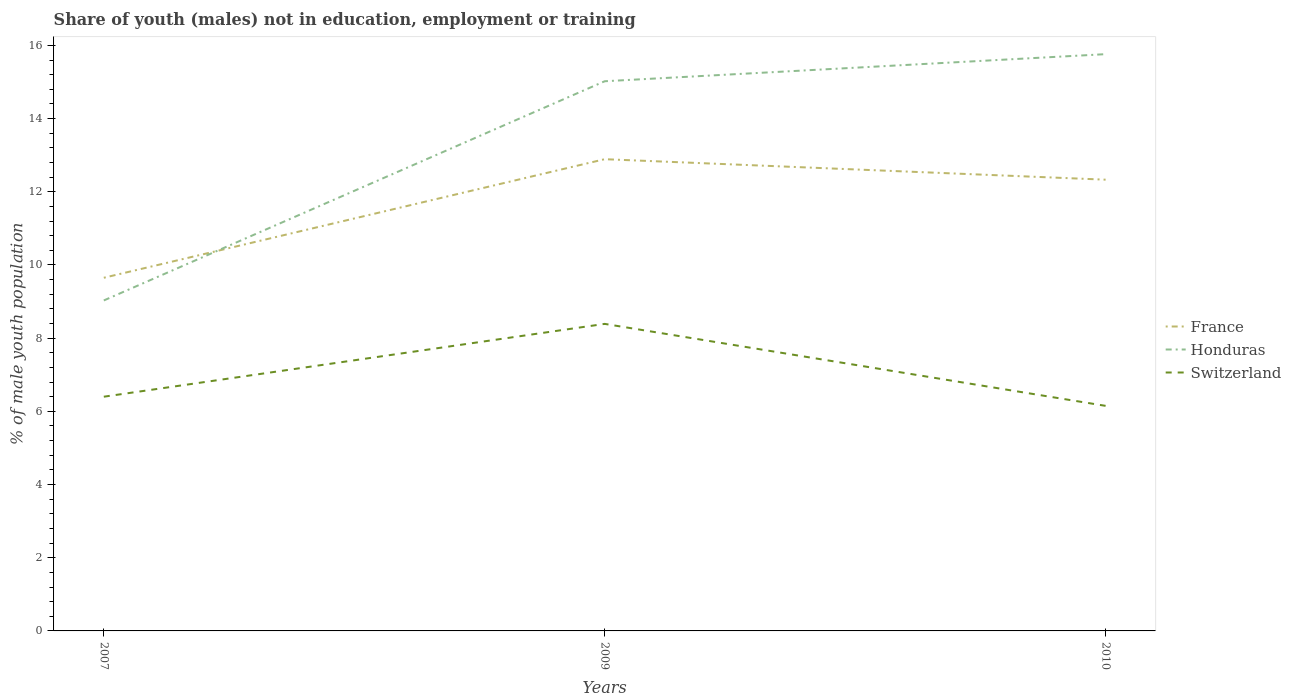How many different coloured lines are there?
Give a very brief answer. 3. Does the line corresponding to France intersect with the line corresponding to Honduras?
Keep it short and to the point. Yes. Is the number of lines equal to the number of legend labels?
Offer a very short reply. Yes. Across all years, what is the maximum percentage of unemployed males population in in France?
Offer a very short reply. 9.65. In which year was the percentage of unemployed males population in in Switzerland maximum?
Offer a terse response. 2010. What is the total percentage of unemployed males population in in France in the graph?
Offer a terse response. -2.68. What is the difference between the highest and the second highest percentage of unemployed males population in in Honduras?
Ensure brevity in your answer.  6.73. Is the percentage of unemployed males population in in France strictly greater than the percentage of unemployed males population in in Switzerland over the years?
Your answer should be very brief. No. How many lines are there?
Provide a short and direct response. 3. What is the difference between two consecutive major ticks on the Y-axis?
Provide a succinct answer. 2. Does the graph contain grids?
Your answer should be compact. No. Where does the legend appear in the graph?
Provide a succinct answer. Center right. How many legend labels are there?
Give a very brief answer. 3. What is the title of the graph?
Offer a terse response. Share of youth (males) not in education, employment or training. What is the label or title of the Y-axis?
Offer a very short reply. % of male youth population. What is the % of male youth population in France in 2007?
Your response must be concise. 9.65. What is the % of male youth population of Honduras in 2007?
Give a very brief answer. 9.03. What is the % of male youth population of Switzerland in 2007?
Make the answer very short. 6.4. What is the % of male youth population in France in 2009?
Make the answer very short. 12.89. What is the % of male youth population in Honduras in 2009?
Keep it short and to the point. 15.02. What is the % of male youth population of Switzerland in 2009?
Provide a short and direct response. 8.39. What is the % of male youth population of France in 2010?
Your answer should be very brief. 12.33. What is the % of male youth population in Honduras in 2010?
Provide a succinct answer. 15.76. What is the % of male youth population in Switzerland in 2010?
Your response must be concise. 6.15. Across all years, what is the maximum % of male youth population of France?
Keep it short and to the point. 12.89. Across all years, what is the maximum % of male youth population in Honduras?
Ensure brevity in your answer.  15.76. Across all years, what is the maximum % of male youth population in Switzerland?
Provide a succinct answer. 8.39. Across all years, what is the minimum % of male youth population of France?
Your answer should be compact. 9.65. Across all years, what is the minimum % of male youth population of Honduras?
Offer a very short reply. 9.03. Across all years, what is the minimum % of male youth population in Switzerland?
Make the answer very short. 6.15. What is the total % of male youth population of France in the graph?
Offer a very short reply. 34.87. What is the total % of male youth population of Honduras in the graph?
Keep it short and to the point. 39.81. What is the total % of male youth population in Switzerland in the graph?
Offer a terse response. 20.94. What is the difference between the % of male youth population of France in 2007 and that in 2009?
Make the answer very short. -3.24. What is the difference between the % of male youth population of Honduras in 2007 and that in 2009?
Provide a short and direct response. -5.99. What is the difference between the % of male youth population in Switzerland in 2007 and that in 2009?
Make the answer very short. -1.99. What is the difference between the % of male youth population of France in 2007 and that in 2010?
Your response must be concise. -2.68. What is the difference between the % of male youth population in Honduras in 2007 and that in 2010?
Keep it short and to the point. -6.73. What is the difference between the % of male youth population of France in 2009 and that in 2010?
Your answer should be compact. 0.56. What is the difference between the % of male youth population in Honduras in 2009 and that in 2010?
Ensure brevity in your answer.  -0.74. What is the difference between the % of male youth population of Switzerland in 2009 and that in 2010?
Provide a short and direct response. 2.24. What is the difference between the % of male youth population in France in 2007 and the % of male youth population in Honduras in 2009?
Ensure brevity in your answer.  -5.37. What is the difference between the % of male youth population in France in 2007 and the % of male youth population in Switzerland in 2009?
Offer a very short reply. 1.26. What is the difference between the % of male youth population of Honduras in 2007 and the % of male youth population of Switzerland in 2009?
Ensure brevity in your answer.  0.64. What is the difference between the % of male youth population in France in 2007 and the % of male youth population in Honduras in 2010?
Your answer should be very brief. -6.11. What is the difference between the % of male youth population in Honduras in 2007 and the % of male youth population in Switzerland in 2010?
Your answer should be compact. 2.88. What is the difference between the % of male youth population in France in 2009 and the % of male youth population in Honduras in 2010?
Provide a short and direct response. -2.87. What is the difference between the % of male youth population in France in 2009 and the % of male youth population in Switzerland in 2010?
Your response must be concise. 6.74. What is the difference between the % of male youth population in Honduras in 2009 and the % of male youth population in Switzerland in 2010?
Give a very brief answer. 8.87. What is the average % of male youth population in France per year?
Provide a succinct answer. 11.62. What is the average % of male youth population of Honduras per year?
Give a very brief answer. 13.27. What is the average % of male youth population of Switzerland per year?
Your answer should be compact. 6.98. In the year 2007, what is the difference between the % of male youth population in France and % of male youth population in Honduras?
Keep it short and to the point. 0.62. In the year 2007, what is the difference between the % of male youth population in Honduras and % of male youth population in Switzerland?
Provide a short and direct response. 2.63. In the year 2009, what is the difference between the % of male youth population in France and % of male youth population in Honduras?
Provide a short and direct response. -2.13. In the year 2009, what is the difference between the % of male youth population of France and % of male youth population of Switzerland?
Make the answer very short. 4.5. In the year 2009, what is the difference between the % of male youth population of Honduras and % of male youth population of Switzerland?
Ensure brevity in your answer.  6.63. In the year 2010, what is the difference between the % of male youth population in France and % of male youth population in Honduras?
Offer a terse response. -3.43. In the year 2010, what is the difference between the % of male youth population of France and % of male youth population of Switzerland?
Offer a terse response. 6.18. In the year 2010, what is the difference between the % of male youth population of Honduras and % of male youth population of Switzerland?
Make the answer very short. 9.61. What is the ratio of the % of male youth population of France in 2007 to that in 2009?
Your response must be concise. 0.75. What is the ratio of the % of male youth population in Honduras in 2007 to that in 2009?
Offer a very short reply. 0.6. What is the ratio of the % of male youth population in Switzerland in 2007 to that in 2009?
Offer a terse response. 0.76. What is the ratio of the % of male youth population in France in 2007 to that in 2010?
Make the answer very short. 0.78. What is the ratio of the % of male youth population of Honduras in 2007 to that in 2010?
Provide a succinct answer. 0.57. What is the ratio of the % of male youth population in Switzerland in 2007 to that in 2010?
Keep it short and to the point. 1.04. What is the ratio of the % of male youth population of France in 2009 to that in 2010?
Your answer should be very brief. 1.05. What is the ratio of the % of male youth population of Honduras in 2009 to that in 2010?
Offer a very short reply. 0.95. What is the ratio of the % of male youth population in Switzerland in 2009 to that in 2010?
Provide a short and direct response. 1.36. What is the difference between the highest and the second highest % of male youth population of France?
Your answer should be very brief. 0.56. What is the difference between the highest and the second highest % of male youth population in Honduras?
Provide a succinct answer. 0.74. What is the difference between the highest and the second highest % of male youth population in Switzerland?
Your response must be concise. 1.99. What is the difference between the highest and the lowest % of male youth population in France?
Your answer should be compact. 3.24. What is the difference between the highest and the lowest % of male youth population of Honduras?
Provide a succinct answer. 6.73. What is the difference between the highest and the lowest % of male youth population of Switzerland?
Your response must be concise. 2.24. 